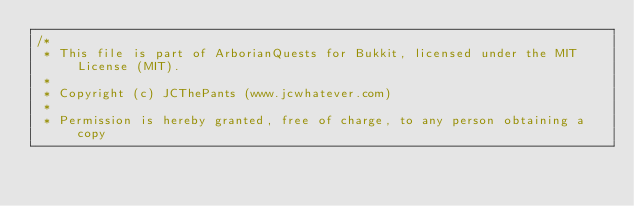<code> <loc_0><loc_0><loc_500><loc_500><_Java_>/*
 * This file is part of ArborianQuests for Bukkit, licensed under the MIT License (MIT).
 *
 * Copyright (c) JCThePants (www.jcwhatever.com)
 *
 * Permission is hereby granted, free of charge, to any person obtaining a copy</code> 